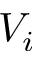Convert formula to latex. <formula><loc_0><loc_0><loc_500><loc_500>V _ { i }</formula> 